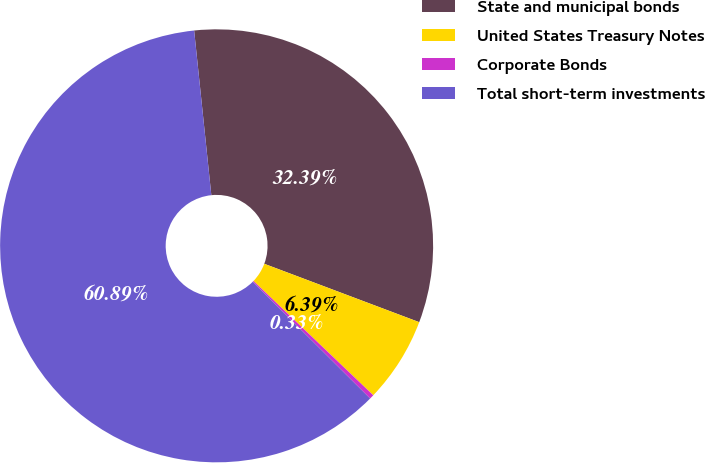Convert chart to OTSL. <chart><loc_0><loc_0><loc_500><loc_500><pie_chart><fcel>State and municipal bonds<fcel>United States Treasury Notes<fcel>Corporate Bonds<fcel>Total short-term investments<nl><fcel>32.39%<fcel>6.39%<fcel>0.33%<fcel>60.89%<nl></chart> 